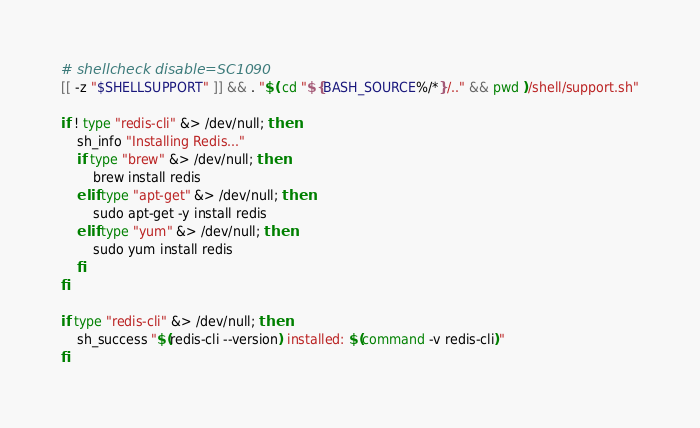Convert code to text. <code><loc_0><loc_0><loc_500><loc_500><_Bash_># shellcheck disable=SC1090
[[ -z "$SHELLSUPPORT" ]] && . "$( cd "${BASH_SOURCE%/*}/.." && pwd )/shell/support.sh"

if ! type "redis-cli" &> /dev/null; then
    sh_info "Installing Redis..."
    if type "brew" &> /dev/null; then
        brew install redis
    elif type "apt-get" &> /dev/null; then
        sudo apt-get -y install redis
    elif type "yum" &> /dev/null; then
        sudo yum install redis
    fi
fi

if type "redis-cli" &> /dev/null; then
    sh_success "$(redis-cli --version) installed: $(command -v redis-cli)"
fi
</code> 